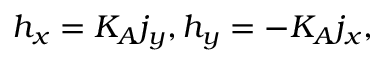Convert formula to latex. <formula><loc_0><loc_0><loc_500><loc_500>h _ { x } = K _ { A } j _ { y } , h _ { y } = - K _ { A } j _ { x } ,</formula> 